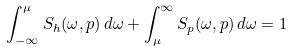Convert formula to latex. <formula><loc_0><loc_0><loc_500><loc_500>\int ^ { \mu } _ { - \infty } S _ { h } ( \omega , p ) \, d \omega + \int ^ { \infty } _ { \mu } S _ { p } ( \omega , p ) \, d \omega = 1</formula> 